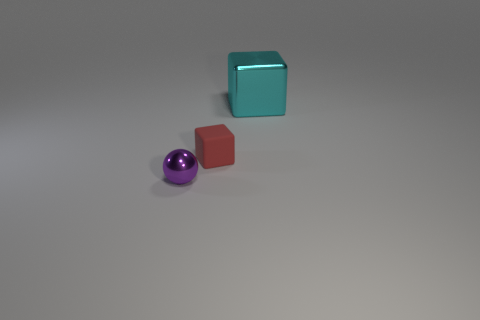What is the size of the metallic object that is in front of the small red thing?
Provide a succinct answer. Small. There is a metal object to the left of the cube that is behind the cube that is on the left side of the big metallic block; what shape is it?
Provide a short and direct response. Sphere. The object that is both behind the small purple metal sphere and in front of the cyan metallic object has what shape?
Your response must be concise. Cube. Are there any blue cubes of the same size as the purple object?
Provide a short and direct response. No. Do the metallic object that is left of the matte cube and the red object have the same shape?
Provide a short and direct response. No. Is the red thing the same shape as the tiny purple thing?
Give a very brief answer. No. Are there any other large metal things that have the same shape as the red object?
Keep it short and to the point. Yes. The thing right of the block that is to the left of the big cyan shiny block is what shape?
Give a very brief answer. Cube. What color is the block in front of the large cyan thing?
Your response must be concise. Red. The sphere that is made of the same material as the cyan block is what size?
Ensure brevity in your answer.  Small. 